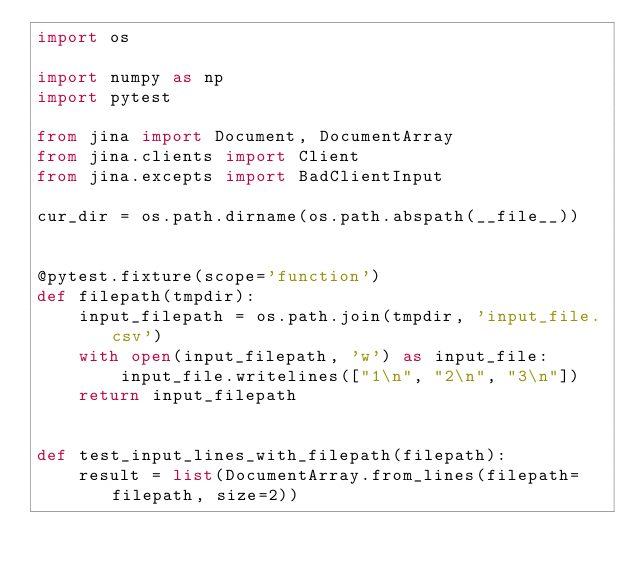Convert code to text. <code><loc_0><loc_0><loc_500><loc_500><_Python_>import os

import numpy as np
import pytest

from jina import Document, DocumentArray
from jina.clients import Client
from jina.excepts import BadClientInput

cur_dir = os.path.dirname(os.path.abspath(__file__))


@pytest.fixture(scope='function')
def filepath(tmpdir):
    input_filepath = os.path.join(tmpdir, 'input_file.csv')
    with open(input_filepath, 'w') as input_file:
        input_file.writelines(["1\n", "2\n", "3\n"])
    return input_filepath


def test_input_lines_with_filepath(filepath):
    result = list(DocumentArray.from_lines(filepath=filepath, size=2))</code> 